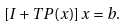Convert formula to latex. <formula><loc_0><loc_0><loc_500><loc_500>\left [ I + T P ( x ) \right ] x = b .</formula> 